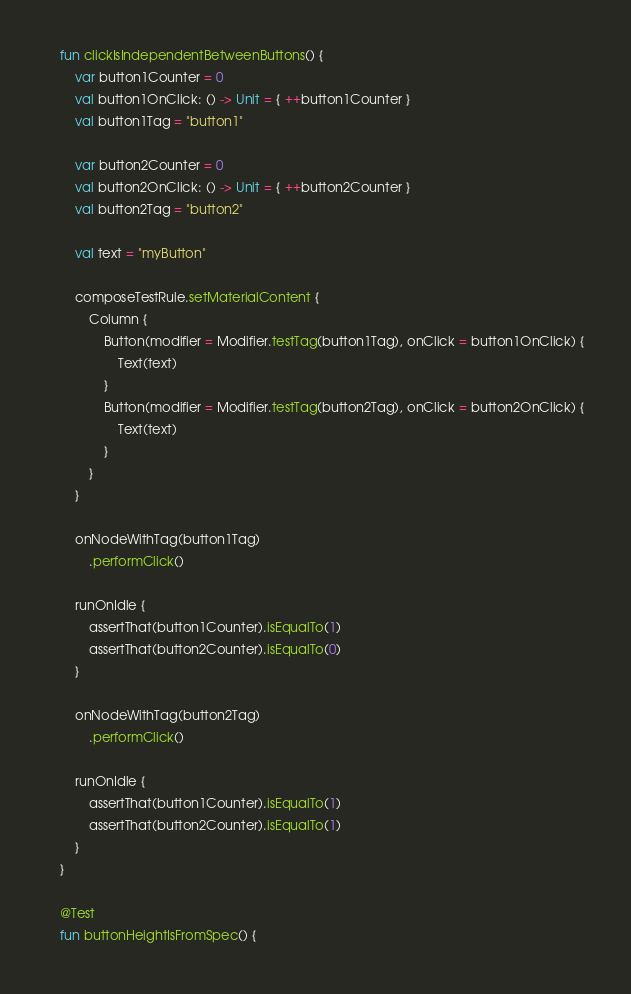Convert code to text. <code><loc_0><loc_0><loc_500><loc_500><_Kotlin_>    fun clickIsIndependentBetweenButtons() {
        var button1Counter = 0
        val button1OnClick: () -> Unit = { ++button1Counter }
        val button1Tag = "button1"

        var button2Counter = 0
        val button2OnClick: () -> Unit = { ++button2Counter }
        val button2Tag = "button2"

        val text = "myButton"

        composeTestRule.setMaterialContent {
            Column {
                Button(modifier = Modifier.testTag(button1Tag), onClick = button1OnClick) {
                    Text(text)
                }
                Button(modifier = Modifier.testTag(button2Tag), onClick = button2OnClick) {
                    Text(text)
                }
            }
        }

        onNodeWithTag(button1Tag)
            .performClick()

        runOnIdle {
            assertThat(button1Counter).isEqualTo(1)
            assertThat(button2Counter).isEqualTo(0)
        }

        onNodeWithTag(button2Tag)
            .performClick()

        runOnIdle {
            assertThat(button1Counter).isEqualTo(1)
            assertThat(button2Counter).isEqualTo(1)
        }
    }

    @Test
    fun buttonHeightIsFromSpec() {</code> 